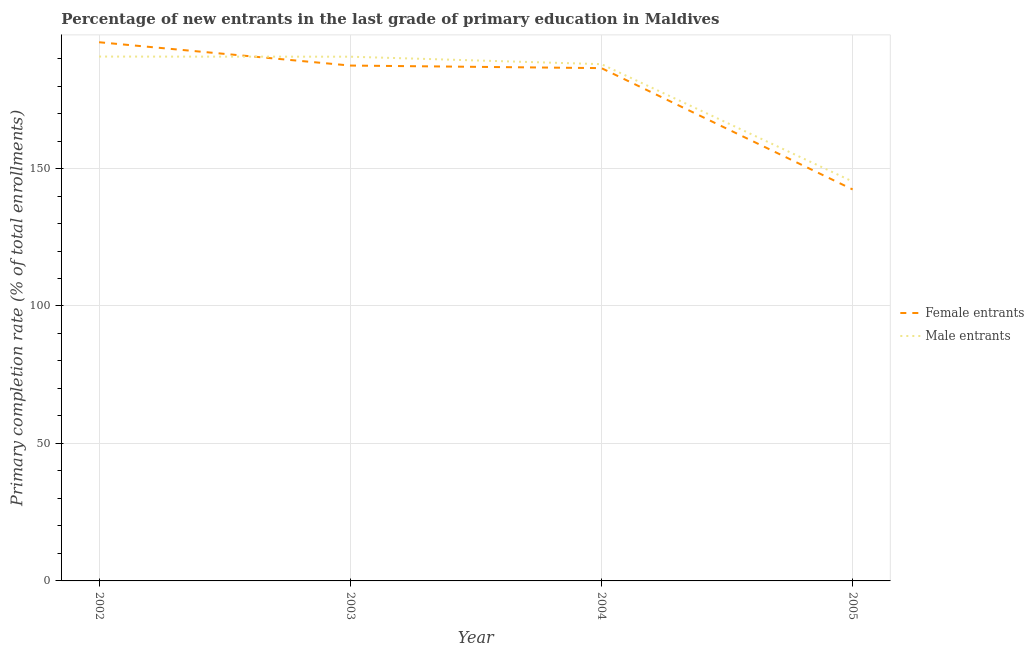How many different coloured lines are there?
Offer a very short reply. 2. Is the number of lines equal to the number of legend labels?
Offer a terse response. Yes. What is the primary completion rate of male entrants in 2005?
Offer a terse response. 145.27. Across all years, what is the maximum primary completion rate of female entrants?
Keep it short and to the point. 195.94. Across all years, what is the minimum primary completion rate of male entrants?
Offer a terse response. 145.27. In which year was the primary completion rate of female entrants minimum?
Offer a very short reply. 2005. What is the total primary completion rate of female entrants in the graph?
Your response must be concise. 712.31. What is the difference between the primary completion rate of male entrants in 2004 and that in 2005?
Keep it short and to the point. 42.69. What is the difference between the primary completion rate of male entrants in 2002 and the primary completion rate of female entrants in 2003?
Provide a short and direct response. 3.27. What is the average primary completion rate of male entrants per year?
Provide a succinct answer. 178.66. In the year 2005, what is the difference between the primary completion rate of male entrants and primary completion rate of female entrants?
Offer a very short reply. 2.88. In how many years, is the primary completion rate of female entrants greater than 50 %?
Give a very brief answer. 4. What is the ratio of the primary completion rate of male entrants in 2003 to that in 2004?
Keep it short and to the point. 1.01. Is the difference between the primary completion rate of male entrants in 2002 and 2003 greater than the difference between the primary completion rate of female entrants in 2002 and 2003?
Your answer should be very brief. No. What is the difference between the highest and the second highest primary completion rate of female entrants?
Your answer should be very brief. 8.48. What is the difference between the highest and the lowest primary completion rate of male entrants?
Keep it short and to the point. 45.45. Is the sum of the primary completion rate of female entrants in 2003 and 2005 greater than the maximum primary completion rate of male entrants across all years?
Your answer should be very brief. Yes. Does the primary completion rate of female entrants monotonically increase over the years?
Your answer should be very brief. No. Is the primary completion rate of male entrants strictly greater than the primary completion rate of female entrants over the years?
Keep it short and to the point. No. Is the primary completion rate of male entrants strictly less than the primary completion rate of female entrants over the years?
Offer a terse response. No. How many years are there in the graph?
Provide a succinct answer. 4. Are the values on the major ticks of Y-axis written in scientific E-notation?
Keep it short and to the point. No. What is the title of the graph?
Your answer should be very brief. Percentage of new entrants in the last grade of primary education in Maldives. Does "Exports" appear as one of the legend labels in the graph?
Ensure brevity in your answer.  No. What is the label or title of the Y-axis?
Give a very brief answer. Primary completion rate (% of total enrollments). What is the Primary completion rate (% of total enrollments) of Female entrants in 2002?
Offer a terse response. 195.94. What is the Primary completion rate (% of total enrollments) of Male entrants in 2002?
Provide a short and direct response. 190.73. What is the Primary completion rate (% of total enrollments) of Female entrants in 2003?
Provide a short and direct response. 187.46. What is the Primary completion rate (% of total enrollments) of Male entrants in 2003?
Your answer should be compact. 190.68. What is the Primary completion rate (% of total enrollments) of Female entrants in 2004?
Ensure brevity in your answer.  186.52. What is the Primary completion rate (% of total enrollments) of Male entrants in 2004?
Offer a terse response. 187.96. What is the Primary completion rate (% of total enrollments) of Female entrants in 2005?
Your response must be concise. 142.39. What is the Primary completion rate (% of total enrollments) of Male entrants in 2005?
Provide a short and direct response. 145.27. Across all years, what is the maximum Primary completion rate (% of total enrollments) of Female entrants?
Provide a succinct answer. 195.94. Across all years, what is the maximum Primary completion rate (% of total enrollments) in Male entrants?
Provide a succinct answer. 190.73. Across all years, what is the minimum Primary completion rate (% of total enrollments) of Female entrants?
Offer a very short reply. 142.39. Across all years, what is the minimum Primary completion rate (% of total enrollments) of Male entrants?
Ensure brevity in your answer.  145.27. What is the total Primary completion rate (% of total enrollments) of Female entrants in the graph?
Provide a short and direct response. 712.31. What is the total Primary completion rate (% of total enrollments) of Male entrants in the graph?
Your answer should be compact. 714.64. What is the difference between the Primary completion rate (% of total enrollments) in Female entrants in 2002 and that in 2003?
Your answer should be compact. 8.48. What is the difference between the Primary completion rate (% of total enrollments) of Male entrants in 2002 and that in 2003?
Provide a short and direct response. 0.05. What is the difference between the Primary completion rate (% of total enrollments) in Female entrants in 2002 and that in 2004?
Offer a terse response. 9.42. What is the difference between the Primary completion rate (% of total enrollments) in Male entrants in 2002 and that in 2004?
Offer a terse response. 2.77. What is the difference between the Primary completion rate (% of total enrollments) of Female entrants in 2002 and that in 2005?
Your answer should be very brief. 53.55. What is the difference between the Primary completion rate (% of total enrollments) of Male entrants in 2002 and that in 2005?
Offer a terse response. 45.45. What is the difference between the Primary completion rate (% of total enrollments) of Female entrants in 2003 and that in 2004?
Keep it short and to the point. 0.93. What is the difference between the Primary completion rate (% of total enrollments) of Male entrants in 2003 and that in 2004?
Offer a terse response. 2.72. What is the difference between the Primary completion rate (% of total enrollments) of Female entrants in 2003 and that in 2005?
Make the answer very short. 45.07. What is the difference between the Primary completion rate (% of total enrollments) of Male entrants in 2003 and that in 2005?
Offer a terse response. 45.41. What is the difference between the Primary completion rate (% of total enrollments) in Female entrants in 2004 and that in 2005?
Provide a short and direct response. 44.13. What is the difference between the Primary completion rate (% of total enrollments) of Male entrants in 2004 and that in 2005?
Keep it short and to the point. 42.69. What is the difference between the Primary completion rate (% of total enrollments) of Female entrants in 2002 and the Primary completion rate (% of total enrollments) of Male entrants in 2003?
Your answer should be very brief. 5.26. What is the difference between the Primary completion rate (% of total enrollments) in Female entrants in 2002 and the Primary completion rate (% of total enrollments) in Male entrants in 2004?
Ensure brevity in your answer.  7.98. What is the difference between the Primary completion rate (% of total enrollments) in Female entrants in 2002 and the Primary completion rate (% of total enrollments) in Male entrants in 2005?
Your answer should be very brief. 50.67. What is the difference between the Primary completion rate (% of total enrollments) of Female entrants in 2003 and the Primary completion rate (% of total enrollments) of Male entrants in 2004?
Provide a short and direct response. -0.51. What is the difference between the Primary completion rate (% of total enrollments) in Female entrants in 2003 and the Primary completion rate (% of total enrollments) in Male entrants in 2005?
Make the answer very short. 42.18. What is the difference between the Primary completion rate (% of total enrollments) of Female entrants in 2004 and the Primary completion rate (% of total enrollments) of Male entrants in 2005?
Give a very brief answer. 41.25. What is the average Primary completion rate (% of total enrollments) in Female entrants per year?
Provide a succinct answer. 178.08. What is the average Primary completion rate (% of total enrollments) in Male entrants per year?
Your answer should be very brief. 178.66. In the year 2002, what is the difference between the Primary completion rate (% of total enrollments) of Female entrants and Primary completion rate (% of total enrollments) of Male entrants?
Your response must be concise. 5.21. In the year 2003, what is the difference between the Primary completion rate (% of total enrollments) in Female entrants and Primary completion rate (% of total enrollments) in Male entrants?
Keep it short and to the point. -3.22. In the year 2004, what is the difference between the Primary completion rate (% of total enrollments) of Female entrants and Primary completion rate (% of total enrollments) of Male entrants?
Make the answer very short. -1.44. In the year 2005, what is the difference between the Primary completion rate (% of total enrollments) of Female entrants and Primary completion rate (% of total enrollments) of Male entrants?
Provide a succinct answer. -2.88. What is the ratio of the Primary completion rate (% of total enrollments) of Female entrants in 2002 to that in 2003?
Keep it short and to the point. 1.05. What is the ratio of the Primary completion rate (% of total enrollments) in Male entrants in 2002 to that in 2003?
Give a very brief answer. 1. What is the ratio of the Primary completion rate (% of total enrollments) of Female entrants in 2002 to that in 2004?
Make the answer very short. 1.05. What is the ratio of the Primary completion rate (% of total enrollments) of Male entrants in 2002 to that in 2004?
Provide a short and direct response. 1.01. What is the ratio of the Primary completion rate (% of total enrollments) of Female entrants in 2002 to that in 2005?
Provide a short and direct response. 1.38. What is the ratio of the Primary completion rate (% of total enrollments) in Male entrants in 2002 to that in 2005?
Ensure brevity in your answer.  1.31. What is the ratio of the Primary completion rate (% of total enrollments) of Female entrants in 2003 to that in 2004?
Keep it short and to the point. 1. What is the ratio of the Primary completion rate (% of total enrollments) in Male entrants in 2003 to that in 2004?
Keep it short and to the point. 1.01. What is the ratio of the Primary completion rate (% of total enrollments) of Female entrants in 2003 to that in 2005?
Provide a succinct answer. 1.32. What is the ratio of the Primary completion rate (% of total enrollments) in Male entrants in 2003 to that in 2005?
Your answer should be compact. 1.31. What is the ratio of the Primary completion rate (% of total enrollments) in Female entrants in 2004 to that in 2005?
Ensure brevity in your answer.  1.31. What is the ratio of the Primary completion rate (% of total enrollments) in Male entrants in 2004 to that in 2005?
Make the answer very short. 1.29. What is the difference between the highest and the second highest Primary completion rate (% of total enrollments) in Female entrants?
Provide a succinct answer. 8.48. What is the difference between the highest and the second highest Primary completion rate (% of total enrollments) of Male entrants?
Your answer should be compact. 0.05. What is the difference between the highest and the lowest Primary completion rate (% of total enrollments) of Female entrants?
Make the answer very short. 53.55. What is the difference between the highest and the lowest Primary completion rate (% of total enrollments) in Male entrants?
Make the answer very short. 45.45. 